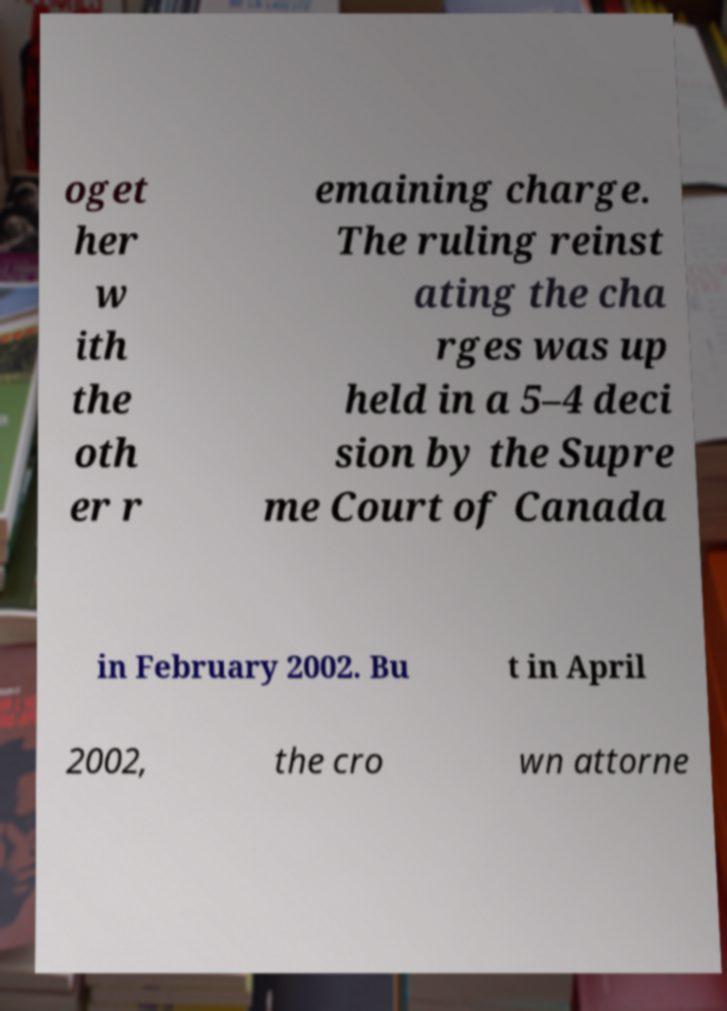Can you read and provide the text displayed in the image?This photo seems to have some interesting text. Can you extract and type it out for me? oget her w ith the oth er r emaining charge. The ruling reinst ating the cha rges was up held in a 5–4 deci sion by the Supre me Court of Canada in February 2002. Bu t in April 2002, the cro wn attorne 